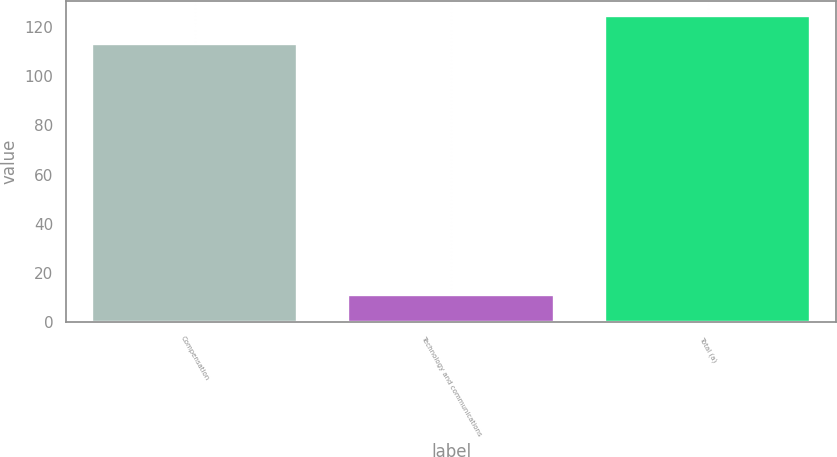<chart> <loc_0><loc_0><loc_500><loc_500><bar_chart><fcel>Compensation<fcel>Technology and communications<fcel>Total (a)<nl><fcel>113<fcel>11<fcel>124.3<nl></chart> 